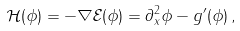Convert formula to latex. <formula><loc_0><loc_0><loc_500><loc_500>\mathcal { H } ( \phi ) = - \nabla \mathcal { E } ( \phi ) = \partial _ { x } ^ { 2 } \phi - g ^ { \prime } ( \phi ) \, ,</formula> 